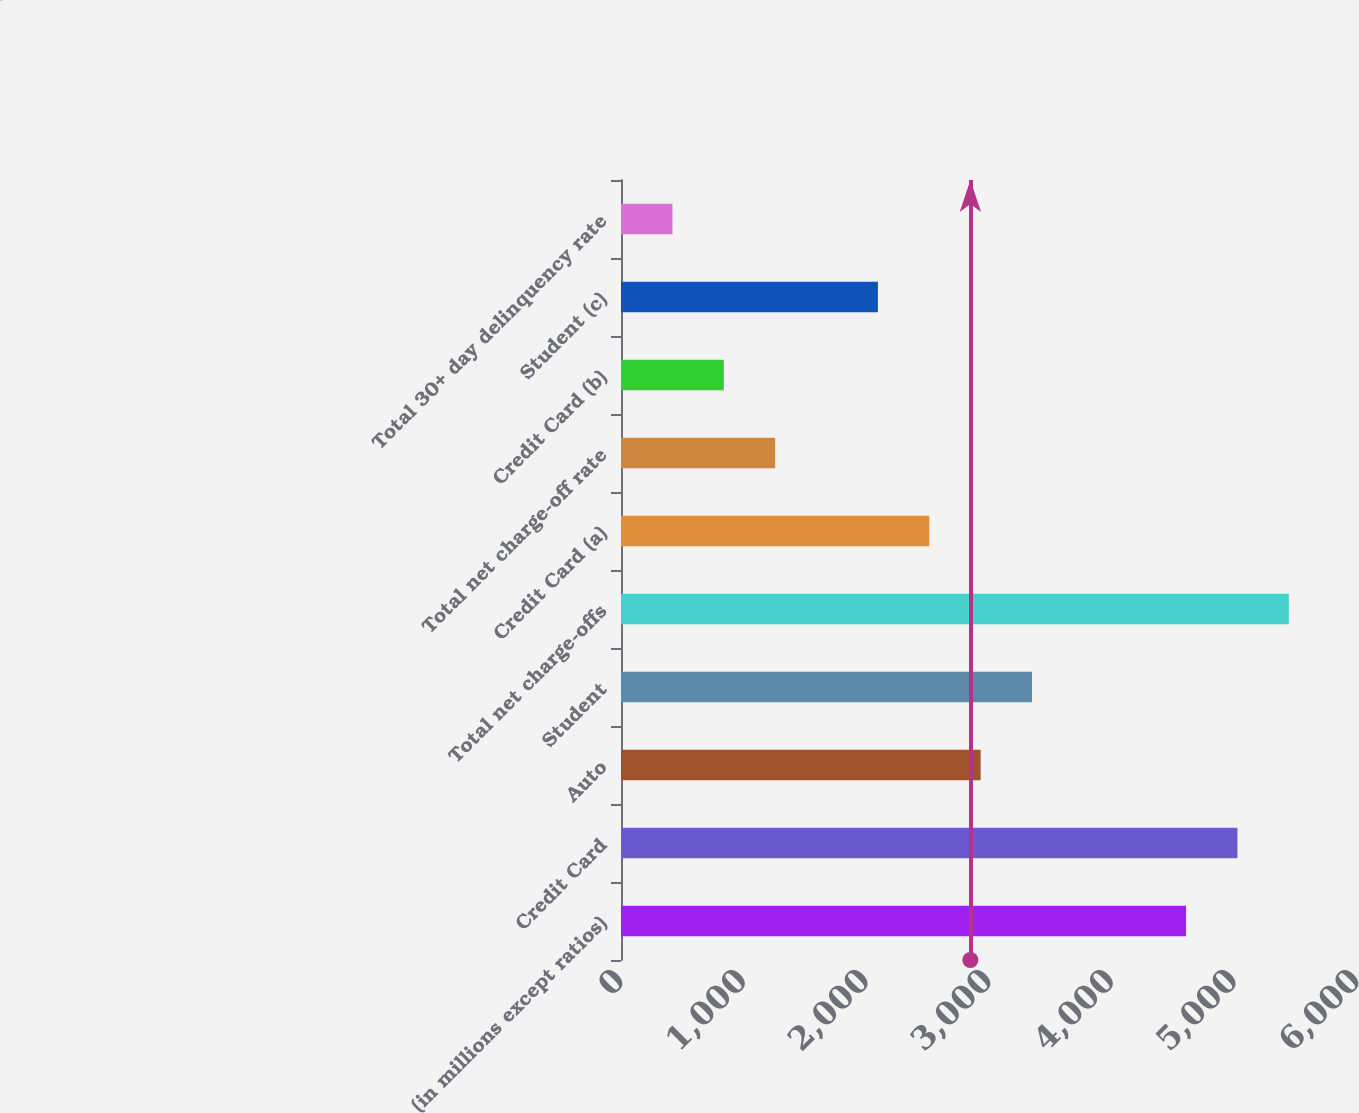<chart> <loc_0><loc_0><loc_500><loc_500><bar_chart><fcel>(in millions except ratios)<fcel>Credit Card<fcel>Auto<fcel>Student<fcel>Total net charge-offs<fcel>Credit Card (a)<fcel>Total net charge-off rate<fcel>Credit Card (b)<fcel>Student (c)<fcel>Total 30+ day delinquency rate<nl><fcel>4606.73<fcel>5025.46<fcel>2931.81<fcel>3350.54<fcel>5444.19<fcel>2513.08<fcel>1256.89<fcel>838.16<fcel>2094.35<fcel>419.43<nl></chart> 